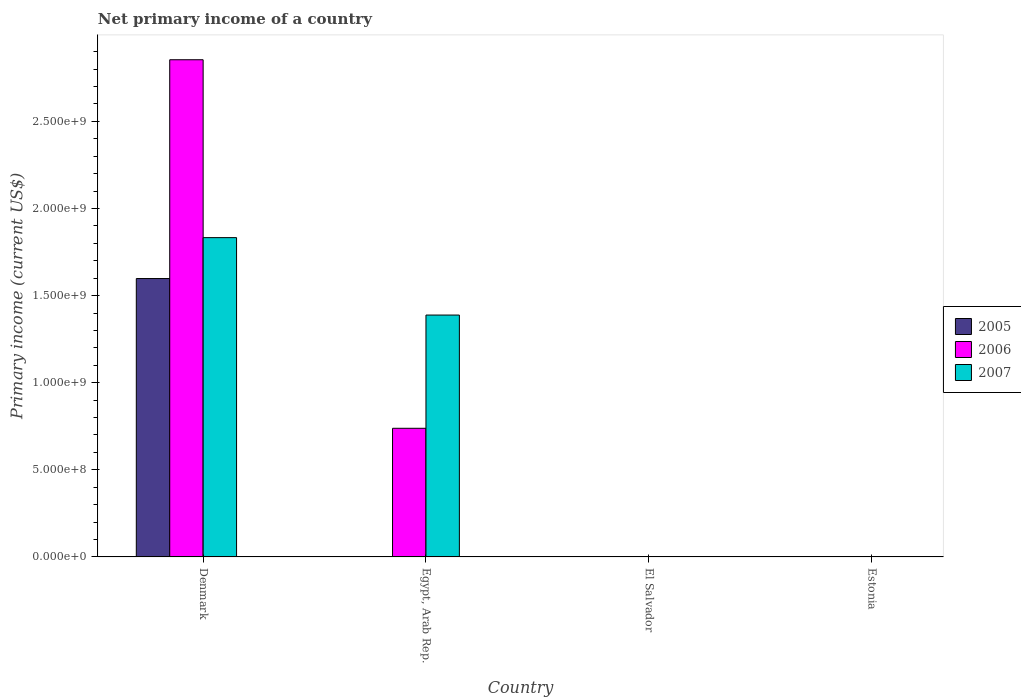How many different coloured bars are there?
Your answer should be very brief. 3. Are the number of bars per tick equal to the number of legend labels?
Keep it short and to the point. No. How many bars are there on the 3rd tick from the right?
Your answer should be very brief. 2. What is the label of the 4th group of bars from the left?
Your answer should be compact. Estonia. What is the primary income in 2007 in Denmark?
Keep it short and to the point. 1.83e+09. Across all countries, what is the maximum primary income in 2005?
Offer a very short reply. 1.60e+09. What is the total primary income in 2005 in the graph?
Your answer should be compact. 1.60e+09. What is the difference between the primary income in 2006 in Denmark and that in Egypt, Arab Rep.?
Ensure brevity in your answer.  2.12e+09. What is the average primary income in 2005 per country?
Provide a short and direct response. 3.99e+08. What is the difference between the primary income of/in 2006 and primary income of/in 2007 in Egypt, Arab Rep.?
Provide a short and direct response. -6.50e+08. What is the ratio of the primary income in 2006 in Denmark to that in Egypt, Arab Rep.?
Your answer should be very brief. 3.87. What is the difference between the highest and the lowest primary income in 2006?
Your response must be concise. 2.85e+09. In how many countries, is the primary income in 2007 greater than the average primary income in 2007 taken over all countries?
Provide a succinct answer. 2. How many bars are there?
Ensure brevity in your answer.  5. Are all the bars in the graph horizontal?
Keep it short and to the point. No. How many countries are there in the graph?
Keep it short and to the point. 4. Does the graph contain any zero values?
Give a very brief answer. Yes. Does the graph contain grids?
Provide a succinct answer. No. Where does the legend appear in the graph?
Make the answer very short. Center right. How many legend labels are there?
Offer a very short reply. 3. What is the title of the graph?
Offer a very short reply. Net primary income of a country. Does "1985" appear as one of the legend labels in the graph?
Make the answer very short. No. What is the label or title of the X-axis?
Ensure brevity in your answer.  Country. What is the label or title of the Y-axis?
Offer a terse response. Primary income (current US$). What is the Primary income (current US$) of 2005 in Denmark?
Offer a terse response. 1.60e+09. What is the Primary income (current US$) of 2006 in Denmark?
Give a very brief answer. 2.85e+09. What is the Primary income (current US$) in 2007 in Denmark?
Make the answer very short. 1.83e+09. What is the Primary income (current US$) of 2006 in Egypt, Arab Rep.?
Give a very brief answer. 7.38e+08. What is the Primary income (current US$) of 2007 in Egypt, Arab Rep.?
Provide a short and direct response. 1.39e+09. What is the Primary income (current US$) of 2006 in El Salvador?
Offer a terse response. 0. What is the Primary income (current US$) in 2006 in Estonia?
Your response must be concise. 0. Across all countries, what is the maximum Primary income (current US$) of 2005?
Your answer should be compact. 1.60e+09. Across all countries, what is the maximum Primary income (current US$) in 2006?
Keep it short and to the point. 2.85e+09. Across all countries, what is the maximum Primary income (current US$) of 2007?
Make the answer very short. 1.83e+09. Across all countries, what is the minimum Primary income (current US$) in 2006?
Provide a succinct answer. 0. Across all countries, what is the minimum Primary income (current US$) in 2007?
Offer a terse response. 0. What is the total Primary income (current US$) in 2005 in the graph?
Your response must be concise. 1.60e+09. What is the total Primary income (current US$) in 2006 in the graph?
Offer a very short reply. 3.59e+09. What is the total Primary income (current US$) in 2007 in the graph?
Your response must be concise. 3.22e+09. What is the difference between the Primary income (current US$) in 2006 in Denmark and that in Egypt, Arab Rep.?
Keep it short and to the point. 2.12e+09. What is the difference between the Primary income (current US$) of 2007 in Denmark and that in Egypt, Arab Rep.?
Keep it short and to the point. 4.44e+08. What is the difference between the Primary income (current US$) in 2005 in Denmark and the Primary income (current US$) in 2006 in Egypt, Arab Rep.?
Offer a very short reply. 8.60e+08. What is the difference between the Primary income (current US$) in 2005 in Denmark and the Primary income (current US$) in 2007 in Egypt, Arab Rep.?
Offer a terse response. 2.10e+08. What is the difference between the Primary income (current US$) of 2006 in Denmark and the Primary income (current US$) of 2007 in Egypt, Arab Rep.?
Ensure brevity in your answer.  1.47e+09. What is the average Primary income (current US$) in 2005 per country?
Ensure brevity in your answer.  3.99e+08. What is the average Primary income (current US$) of 2006 per country?
Offer a terse response. 8.98e+08. What is the average Primary income (current US$) of 2007 per country?
Your answer should be compact. 8.05e+08. What is the difference between the Primary income (current US$) of 2005 and Primary income (current US$) of 2006 in Denmark?
Your answer should be very brief. -1.26e+09. What is the difference between the Primary income (current US$) of 2005 and Primary income (current US$) of 2007 in Denmark?
Ensure brevity in your answer.  -2.35e+08. What is the difference between the Primary income (current US$) in 2006 and Primary income (current US$) in 2007 in Denmark?
Keep it short and to the point. 1.02e+09. What is the difference between the Primary income (current US$) of 2006 and Primary income (current US$) of 2007 in Egypt, Arab Rep.?
Keep it short and to the point. -6.50e+08. What is the ratio of the Primary income (current US$) in 2006 in Denmark to that in Egypt, Arab Rep.?
Make the answer very short. 3.87. What is the ratio of the Primary income (current US$) of 2007 in Denmark to that in Egypt, Arab Rep.?
Your response must be concise. 1.32. What is the difference between the highest and the lowest Primary income (current US$) of 2005?
Your answer should be compact. 1.60e+09. What is the difference between the highest and the lowest Primary income (current US$) in 2006?
Your answer should be very brief. 2.85e+09. What is the difference between the highest and the lowest Primary income (current US$) of 2007?
Offer a very short reply. 1.83e+09. 